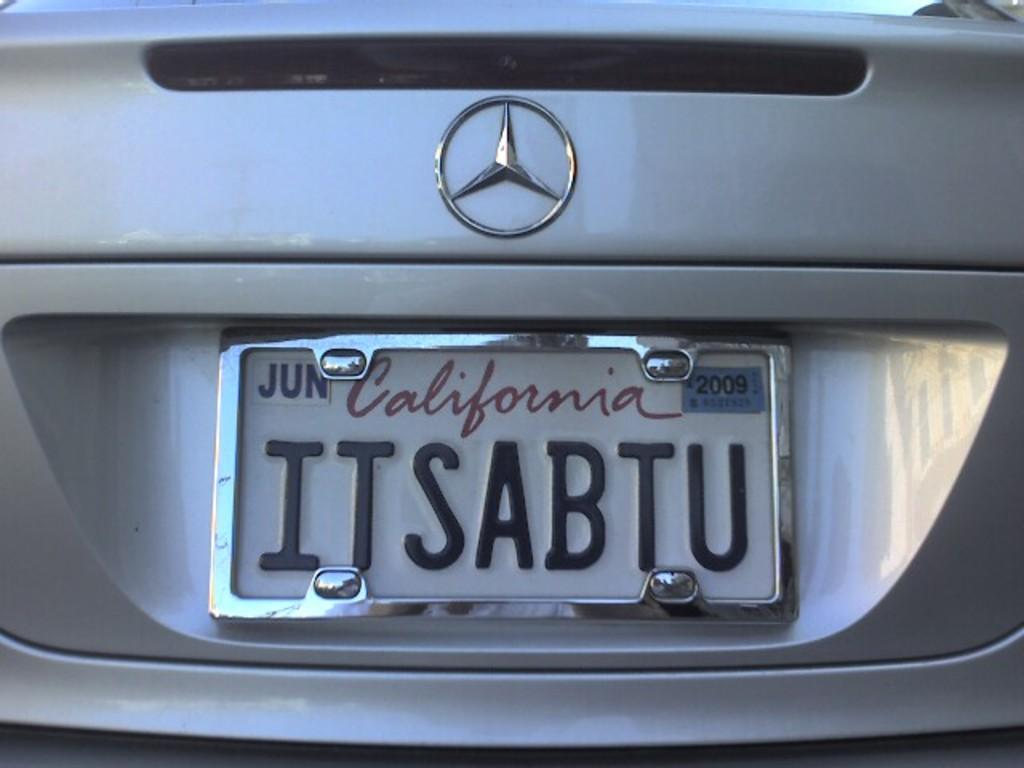Provide a one-sentence caption for the provided image. the word California is on a license plate. 